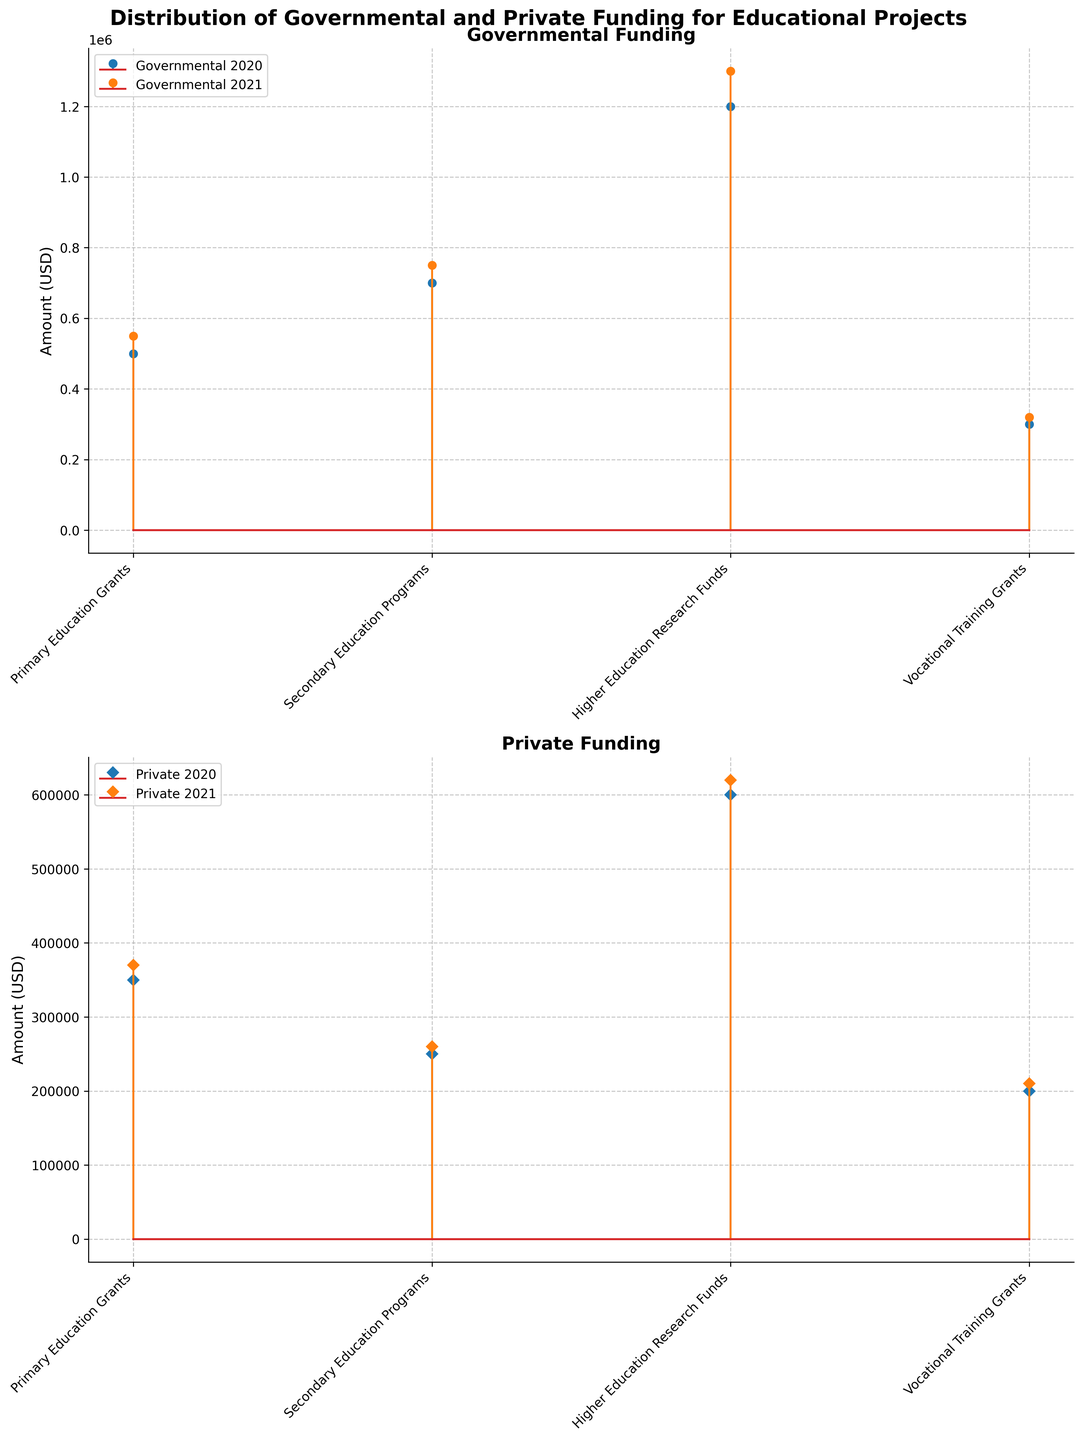What is the title of the plot? The title is displayed at the top of the plot. It is the text string that introduces the main topic of the plot.
Answer: Distribution of Governmental and Private Funding for Educational Projects What categories of educational projects are shown in the plots? The categories are listed on the x-axis of the plot. They represent the different types of educational projects that received funding.
Answer: Primary Education Grants, Secondary Education Programs, Higher Education Research Funds, Vocational Training Grants Which funding source received more funding for Primary Education Grants in 2020? Look at the height of the stem for Primary Education Grants in 2020 on both plots. Compare the heights to determine which is higher.
Answer: Governmental What is the total amount of funding for Secondary Education Programs in 2021 for both sources combined? Identify the amounts for Secondary Education Programs in 2021 from both plots, then sum them up: 750,000 (Governmental) + 260,000 (Private).
Answer: 1,010,000 How did the funding for Higher Education Research Funds change from 2020 to 2021 for private sources? Compare the heights of the stems for Higher Education Research Funds for private sources between the years 2020 and 2021.
Answer: Increased Which category received the least governmental funding in 2020? Look at the heights of the stems on the Governmental Funding plot for 2020. Identify the category with the shortest stem.
Answer: Vocational Training Grants Is the funding amount for Vocational Training Grants greater or lesser in 2021 compared to 2020 for private sources? Compare the heights of the stems for Vocational Training Grants for private sources between the years 2020 and 2021.
Answer: Greater What is the average amount of governmental funding for all categories in 2021? Identify all governmental funding amounts for 2021: 550,000, 750,000, 1,300,000, 320,000. Sum them up and divide by 4: (550,000 + 750,000 + 1,300,000 + 320,000) / 4.
Answer: 730,000 Which category shows an equal amount of private funding for both 2020 and 2021? Look at the heights of the stems for each category in both years for private sources. Identify if any category has stems of equal height in both years.
Answer: Vocational Training Grants Is the total governmental funding for Higher Education Research Funds more than 2 million over the two years? Sum the governmental funding amounts for Higher Education Research Funds for both years: 1,200,000 (2020) + 1,300,000 (2021). Check if the sum is greater than 2,000,000.
Answer: Yes 